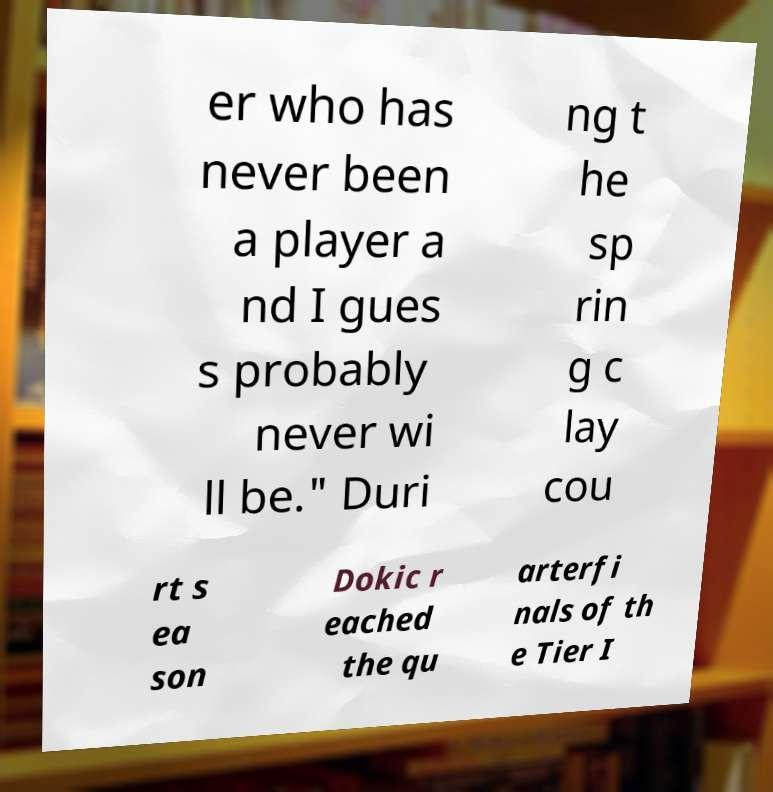Please read and relay the text visible in this image. What does it say? er who has never been a player a nd I gues s probably never wi ll be." Duri ng t he sp rin g c lay cou rt s ea son Dokic r eached the qu arterfi nals of th e Tier I 